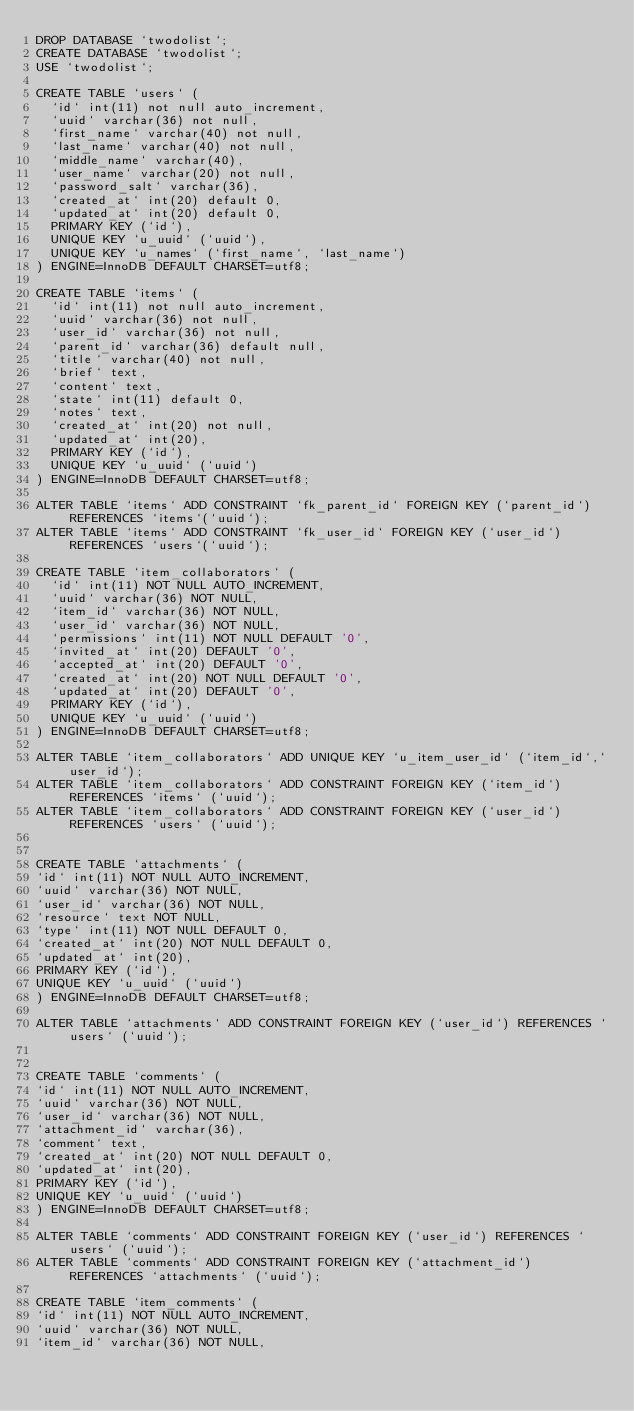Convert code to text. <code><loc_0><loc_0><loc_500><loc_500><_SQL_>DROP DATABASE `twodolist`;
CREATE DATABASE `twodolist`;
USE `twodolist`;

CREATE TABLE `users` (
  `id` int(11) not null auto_increment,
  `uuid` varchar(36) not null,
  `first_name` varchar(40) not null,
  `last_name` varchar(40) not null,
  `middle_name` varchar(40),
  `user_name` varchar(20) not null,
  `password_salt` varchar(36),
  `created_at` int(20) default 0,
  `updated_at` int(20) default 0,
  PRIMARY KEY (`id`),
  UNIQUE KEY `u_uuid` (`uuid`),
  UNIQUE KEY `u_names` (`first_name`, `last_name`)
) ENGINE=InnoDB DEFAULT CHARSET=utf8;

CREATE TABLE `items` (
  `id` int(11) not null auto_increment,
  `uuid` varchar(36) not null,
  `user_id` varchar(36) not null,
  `parent_id` varchar(36) default null,
  `title` varchar(40) not null,
  `brief` text,
  `content` text,
  `state` int(11) default 0,
  `notes` text,
  `created_at` int(20) not null,
  `updated_at` int(20),
  PRIMARY KEY (`id`),
  UNIQUE KEY `u_uuid` (`uuid`)
) ENGINE=InnoDB DEFAULT CHARSET=utf8;

ALTER TABLE `items` ADD CONSTRAINT `fk_parent_id` FOREIGN KEY (`parent_id`) REFERENCES `items`(`uuid`);
ALTER TABLE `items` ADD CONSTRAINT `fk_user_id` FOREIGN KEY (`user_id`) REFERENCES `users`(`uuid`);

CREATE TABLE `item_collaborators` (
  `id` int(11) NOT NULL AUTO_INCREMENT,
  `uuid` varchar(36) NOT NULL,
  `item_id` varchar(36) NOT NULL,
  `user_id` varchar(36) NOT NULL,
  `permissions` int(11) NOT NULL DEFAULT '0',
  `invited_at` int(20) DEFAULT '0',
  `accepted_at` int(20) DEFAULT '0',
  `created_at` int(20) NOT NULL DEFAULT '0',
  `updated_at` int(20) DEFAULT '0',
  PRIMARY KEY (`id`),
  UNIQUE KEY `u_uuid` (`uuid`)
) ENGINE=InnoDB DEFAULT CHARSET=utf8;

ALTER TABLE `item_collaborators` ADD UNIQUE KEY `u_item_user_id` (`item_id`,`user_id`);
ALTER TABLE `item_collaborators` ADD CONSTRAINT FOREIGN KEY (`item_id`) REFERENCES `items` (`uuid`);
ALTER TABLE `item_collaborators` ADD CONSTRAINT FOREIGN KEY (`user_id`) REFERENCES `users` (`uuid`);


CREATE TABLE `attachments` (
`id` int(11) NOT NULL AUTO_INCREMENT,
`uuid` varchar(36) NOT NULL,
`user_id` varchar(36) NOT NULL,
`resource` text NOT NULL,
`type` int(11) NOT NULL DEFAULT 0,
`created_at` int(20) NOT NULL DEFAULT 0,
`updated_at` int(20),
PRIMARY KEY (`id`),
UNIQUE KEY `u_uuid` (`uuid`)
) ENGINE=InnoDB DEFAULT CHARSET=utf8;

ALTER TABLE `attachments` ADD CONSTRAINT FOREIGN KEY (`user_id`) REFERENCES `users` (`uuid`);


CREATE TABLE `comments` (
`id` int(11) NOT NULL AUTO_INCREMENT,
`uuid` varchar(36) NOT NULL,
`user_id` varchar(36) NOT NULL,
`attachment_id` varchar(36),
`comment` text,
`created_at` int(20) NOT NULL DEFAULT 0,
`updated_at` int(20),
PRIMARY KEY (`id`),
UNIQUE KEY `u_uuid` (`uuid`)
) ENGINE=InnoDB DEFAULT CHARSET=utf8;

ALTER TABLE `comments` ADD CONSTRAINT FOREIGN KEY (`user_id`) REFERENCES `users` (`uuid`);
ALTER TABLE `comments` ADD CONSTRAINT FOREIGN KEY (`attachment_id`) REFERENCES `attachments` (`uuid`);

CREATE TABLE `item_comments` (
`id` int(11) NOT NULL AUTO_INCREMENT,
`uuid` varchar(36) NOT NULL,
`item_id` varchar(36) NOT NULL,</code> 